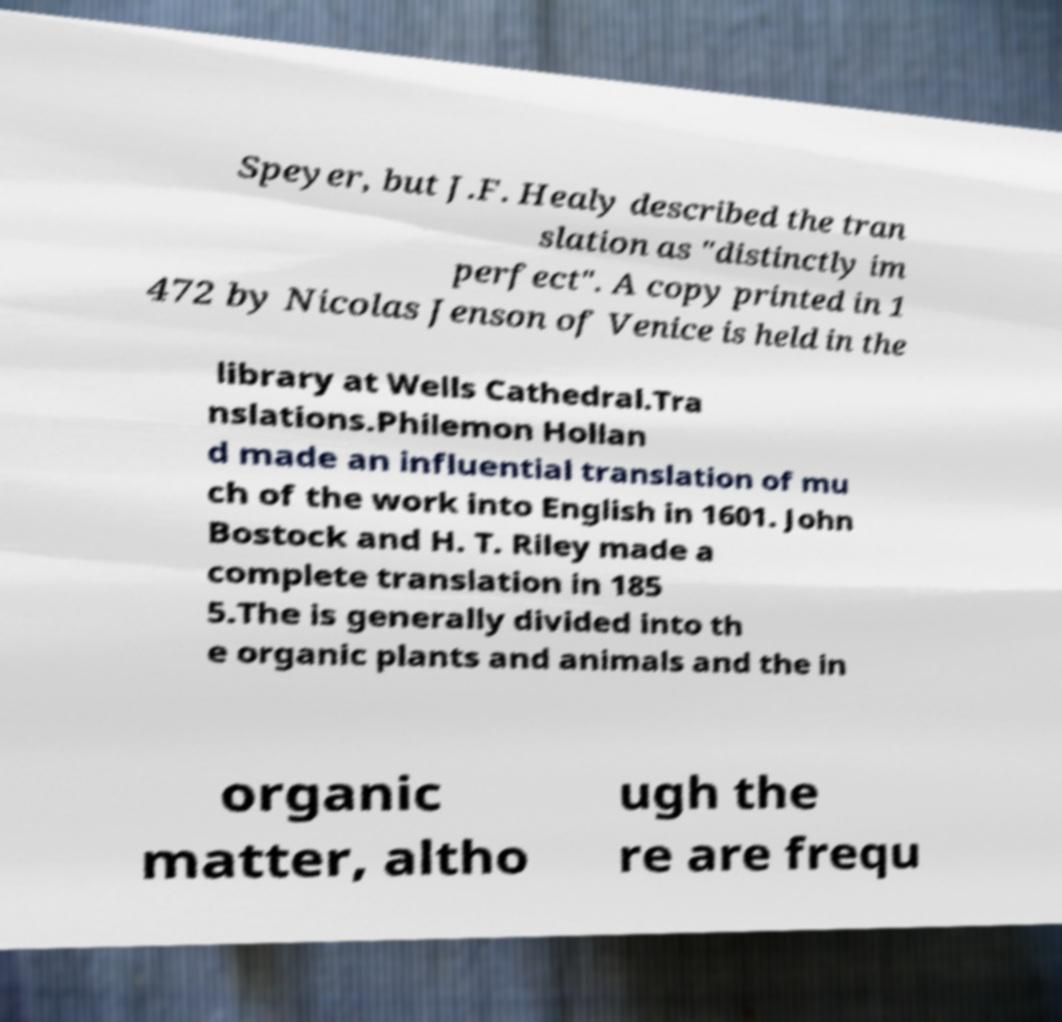What messages or text are displayed in this image? I need them in a readable, typed format. Speyer, but J.F. Healy described the tran slation as "distinctly im perfect". A copy printed in 1 472 by Nicolas Jenson of Venice is held in the library at Wells Cathedral.Tra nslations.Philemon Hollan d made an influential translation of mu ch of the work into English in 1601. John Bostock and H. T. Riley made a complete translation in 185 5.The is generally divided into th e organic plants and animals and the in organic matter, altho ugh the re are frequ 